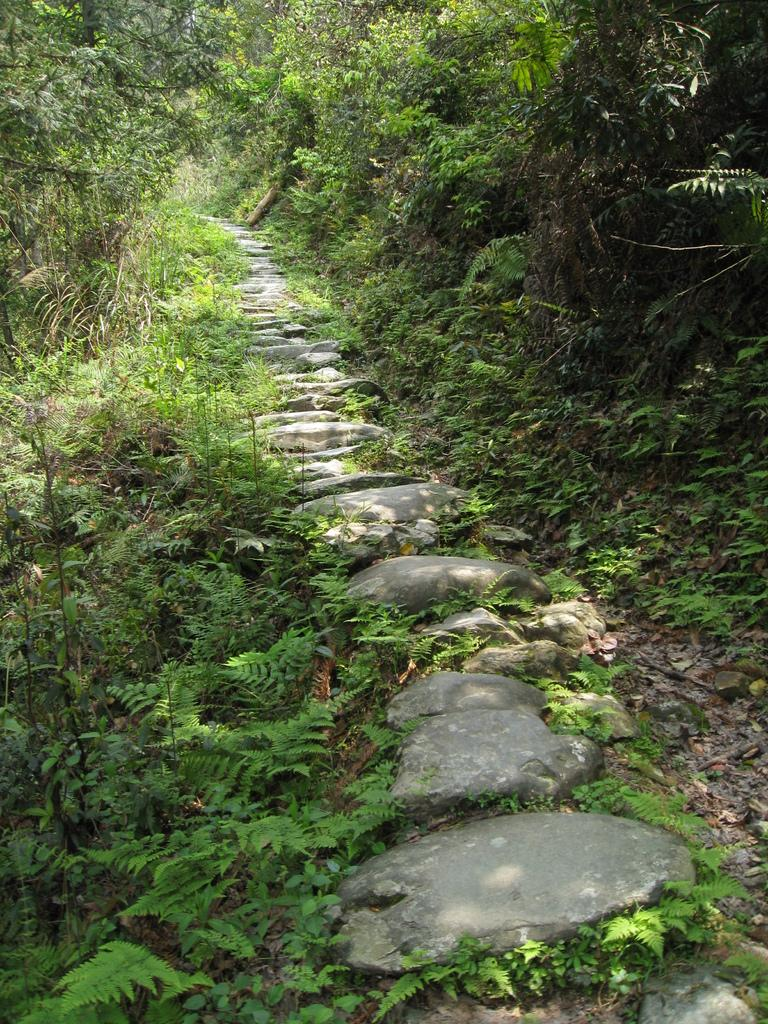What type of vegetation can be seen in the image? There are many plants and trees in the image. Are there any natural features besides plants and trees in the image? Yes, there are rocks in the middle of the image. What is the general layout of the image? The image appears to depict a path or way. What type of salt can be seen on the path in the image? There is no salt present in the image; it features plants, trees, rocks, and a path. What type of trouble is depicted in the image? There is no trouble depicted in the image; it is a natural scene with plants, trees, rocks, and a path. 